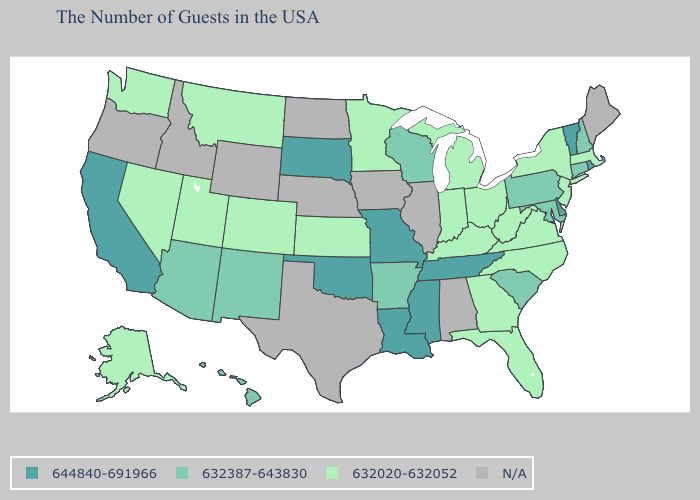How many symbols are there in the legend?
Write a very short answer. 4. Does California have the highest value in the USA?
Concise answer only. Yes. Which states have the lowest value in the West?
Be succinct. Colorado, Utah, Montana, Nevada, Washington, Alaska. What is the value of California?
Quick response, please. 644840-691966. Among the states that border California , which have the lowest value?
Be succinct. Nevada. Which states hav the highest value in the Northeast?
Be succinct. Rhode Island, Vermont. How many symbols are there in the legend?
Short answer required. 4. What is the lowest value in the USA?
Be succinct. 632020-632052. Does New Hampshire have the lowest value in the Northeast?
Concise answer only. No. Which states have the lowest value in the South?
Keep it brief. Virginia, North Carolina, West Virginia, Florida, Georgia, Kentucky. What is the lowest value in the West?
Short answer required. 632020-632052. Name the states that have a value in the range N/A?
Give a very brief answer. Maine, Alabama, Illinois, Iowa, Nebraska, Texas, North Dakota, Wyoming, Idaho, Oregon. Name the states that have a value in the range N/A?
Short answer required. Maine, Alabama, Illinois, Iowa, Nebraska, Texas, North Dakota, Wyoming, Idaho, Oregon. What is the value of South Carolina?
Write a very short answer. 632387-643830. What is the value of Idaho?
Concise answer only. N/A. 